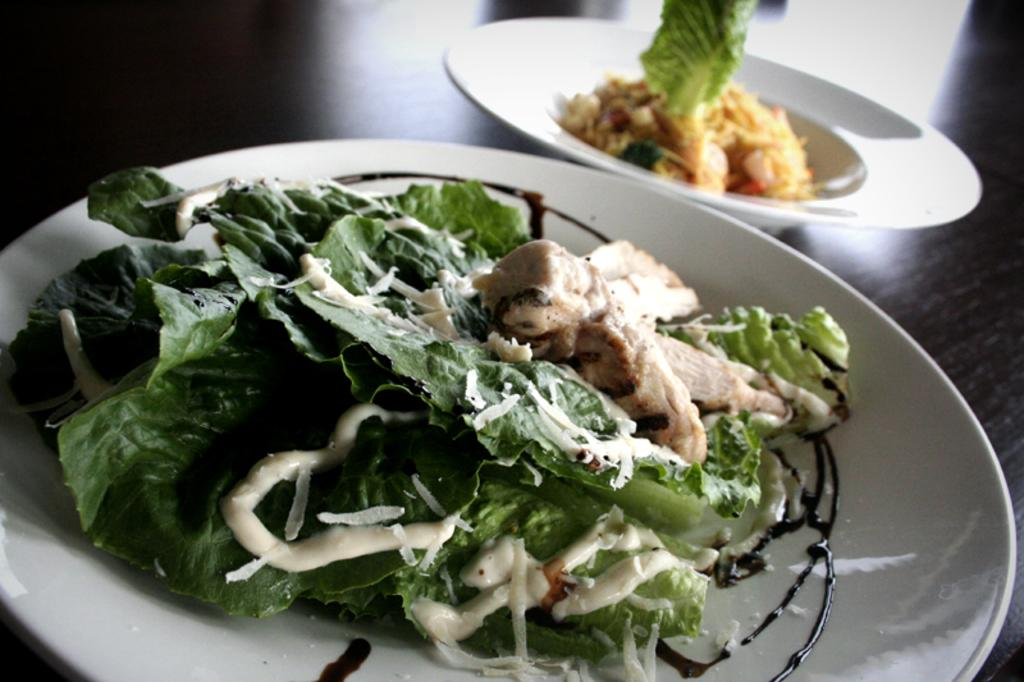What type of objects can be seen in the image? There are food items in the image. How are the food items arranged? The food items are on two white color plates. Where are the plates located? The plates are on a table. What colors can be observed in the food items? The food has colors including green, white, cream, brown, and yellow. What type of needle can be seen in the image? There is no needle present in the image. 